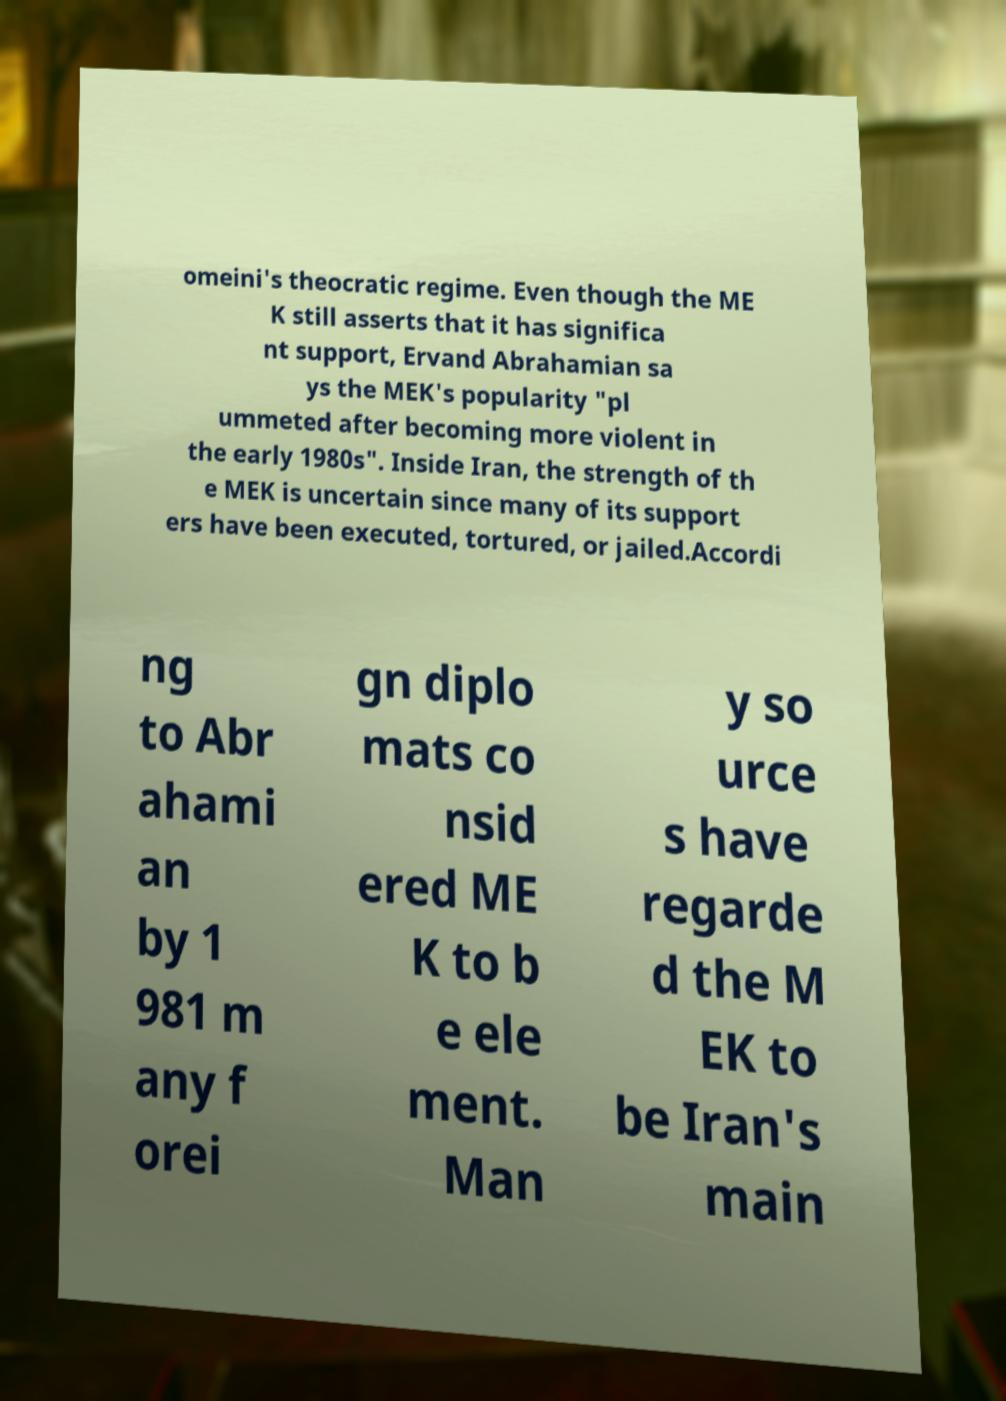For documentation purposes, I need the text within this image transcribed. Could you provide that? omeini's theocratic regime. Even though the ME K still asserts that it has significa nt support, Ervand Abrahamian sa ys the MEK's popularity "pl ummeted after becoming more violent in the early 1980s". Inside Iran, the strength of th e MEK is uncertain since many of its support ers have been executed, tortured, or jailed.Accordi ng to Abr ahami an by 1 981 m any f orei gn diplo mats co nsid ered ME K to b e ele ment. Man y so urce s have regarde d the M EK to be Iran's main 